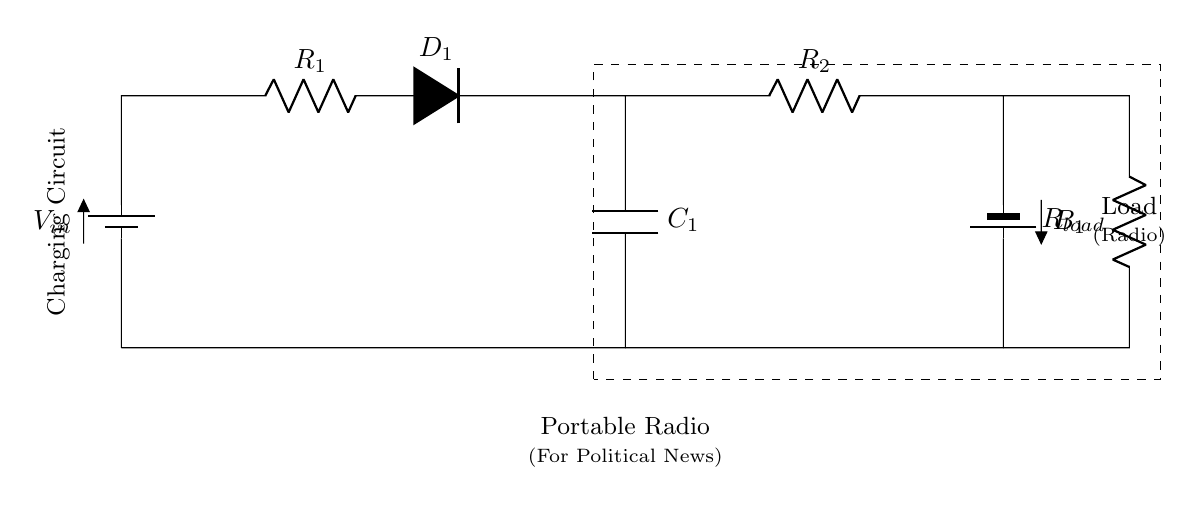What type of circuit is this? This circuit is a charging circuit, specifically designed to charge a battery while powering a load. The presence of a battery and recharge components like a resistor and diode indicates its charging functionality.
Answer: charging circuit What does R1 do in this circuit? R1 is a resistor that limits the current flowing into the charging circuit. By resisting current, it helps to prevent damage to other components and regulates the voltage supplied to the capacitor and load.
Answer: current limiting What is the purpose of D1? D1 is a diode that allows current to flow only in one direction, preventing backflow from the load to the charging circuit. This ensures that the battery charges properly without reverse current disrupting the process.
Answer: current direction How many batteries are present? There are two batteries in the circuit: one as a power source (Vin) and another battery (B1) which stores energy for the portable radio.
Answer: two batteries What is the function of C1 in this charging circuit? C1 is a capacitor that stores charge; it smooths out the voltage fluctuations ensuring a stable power supply for the load (the portable radio). It plays a crucial role in stabilizing the circuit's output voltage.
Answer: charge storage What is the load in this circuit? The load in this circuit is the portable radio, which draws power to remain operational. The radio is an essential component for receiving political news while being powered by the battery.
Answer: portable radio 